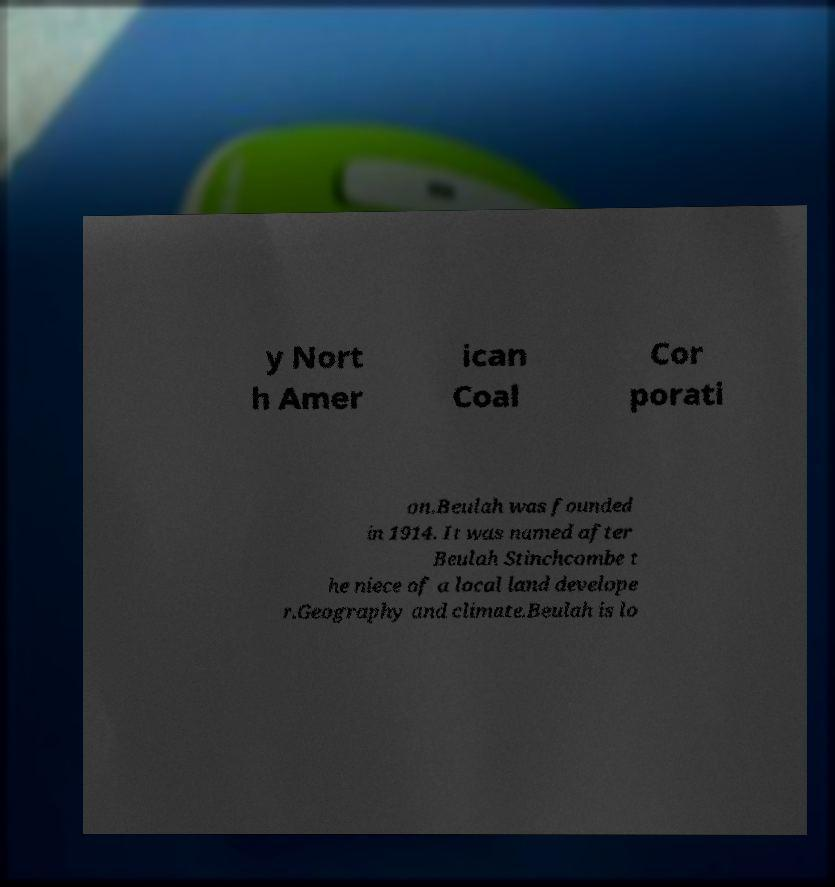Can you read and provide the text displayed in the image?This photo seems to have some interesting text. Can you extract and type it out for me? y Nort h Amer ican Coal Cor porati on.Beulah was founded in 1914. It was named after Beulah Stinchcombe t he niece of a local land develope r.Geography and climate.Beulah is lo 